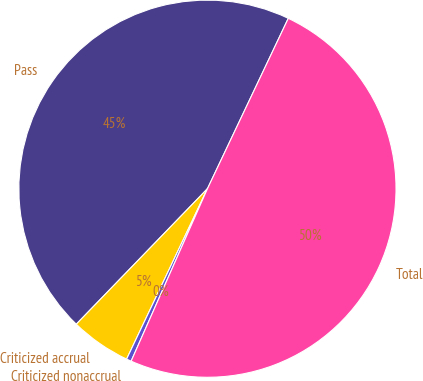Convert chart to OTSL. <chart><loc_0><loc_0><loc_500><loc_500><pie_chart><fcel>Pass<fcel>Criticized accrual<fcel>Criticized nonaccrual<fcel>Total<nl><fcel>44.81%<fcel>5.19%<fcel>0.42%<fcel>49.58%<nl></chart> 